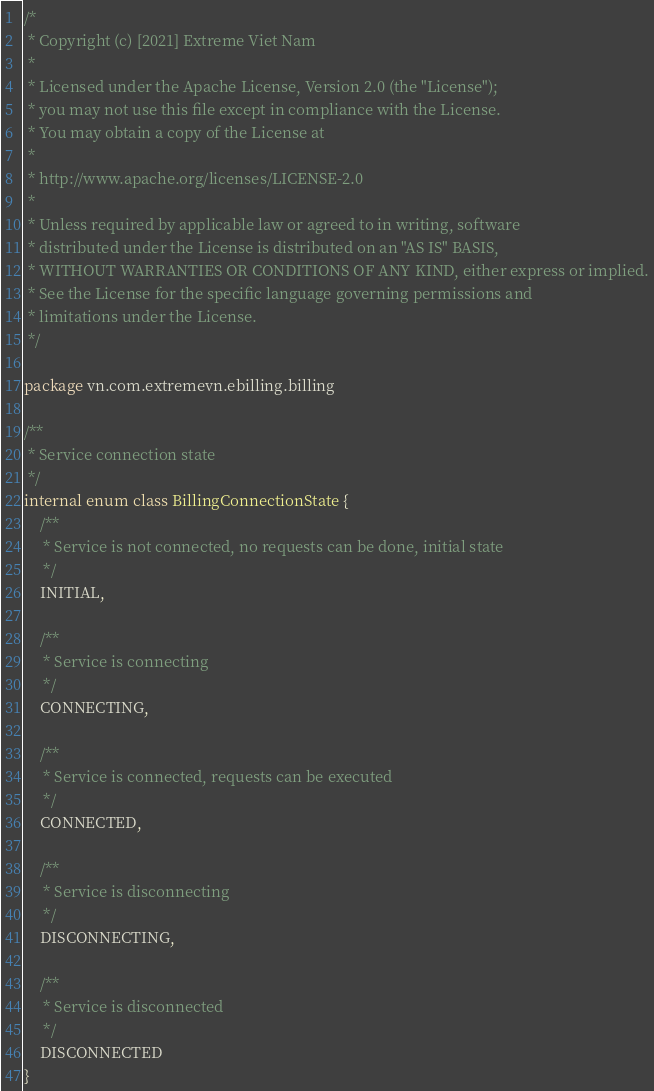<code> <loc_0><loc_0><loc_500><loc_500><_Kotlin_>/*
 * Copyright (c) [2021] Extreme Viet Nam
 *
 * Licensed under the Apache License, Version 2.0 (the "License");
 * you may not use this file except in compliance with the License.
 * You may obtain a copy of the License at
 *
 * http://www.apache.org/licenses/LICENSE-2.0
 *
 * Unless required by applicable law or agreed to in writing, software
 * distributed under the License is distributed on an "AS IS" BASIS,
 * WITHOUT WARRANTIES OR CONDITIONS OF ANY KIND, either express or implied.
 * See the License for the specific language governing permissions and
 * limitations under the License.
 */

package vn.com.extremevn.ebilling.billing

/**
 * Service connection state
 */
internal enum class BillingConnectionState {
    /**
     * Service is not connected, no requests can be done, initial state
     */
    INITIAL,

    /**
     * Service is connecting
     */
    CONNECTING,

    /**
     * Service is connected, requests can be executed
     */
    CONNECTED,

    /**
     * Service is disconnecting
     */
    DISCONNECTING,

    /**
     * Service is disconnected
     */
    DISCONNECTED
}
</code> 